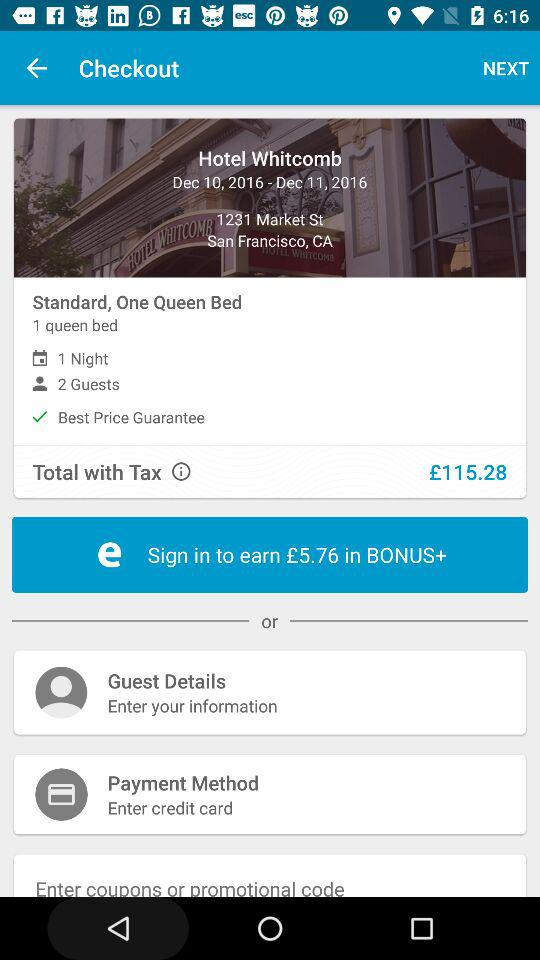How much do I have to pay to book a Kimpton Buchanan Hotel? You have to pay £177 to book a Kimpton Buchanan Hotel. 